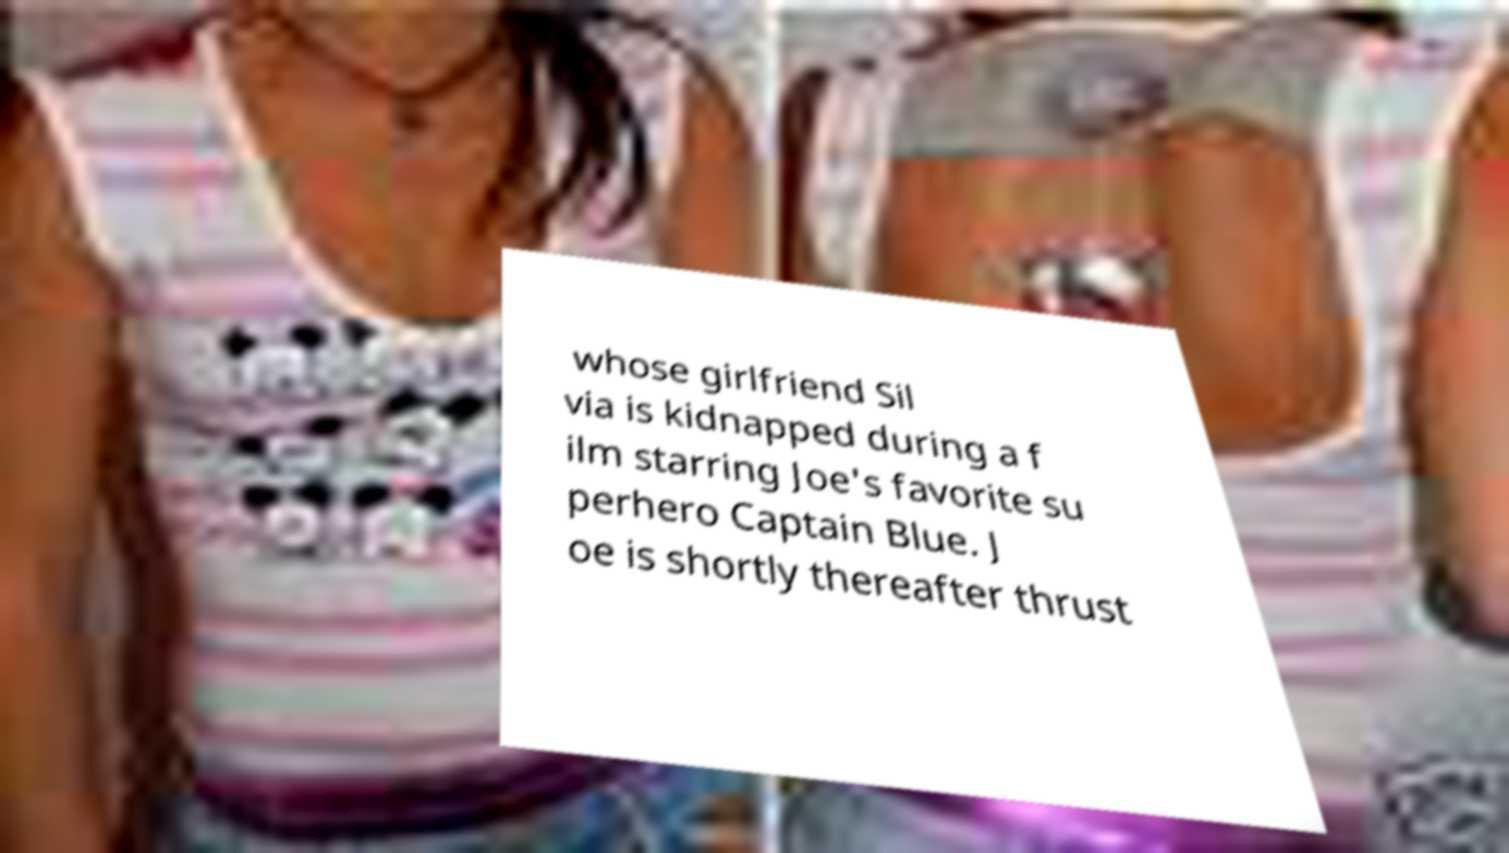Could you assist in decoding the text presented in this image and type it out clearly? whose girlfriend Sil via is kidnapped during a f ilm starring Joe's favorite su perhero Captain Blue. J oe is shortly thereafter thrust 